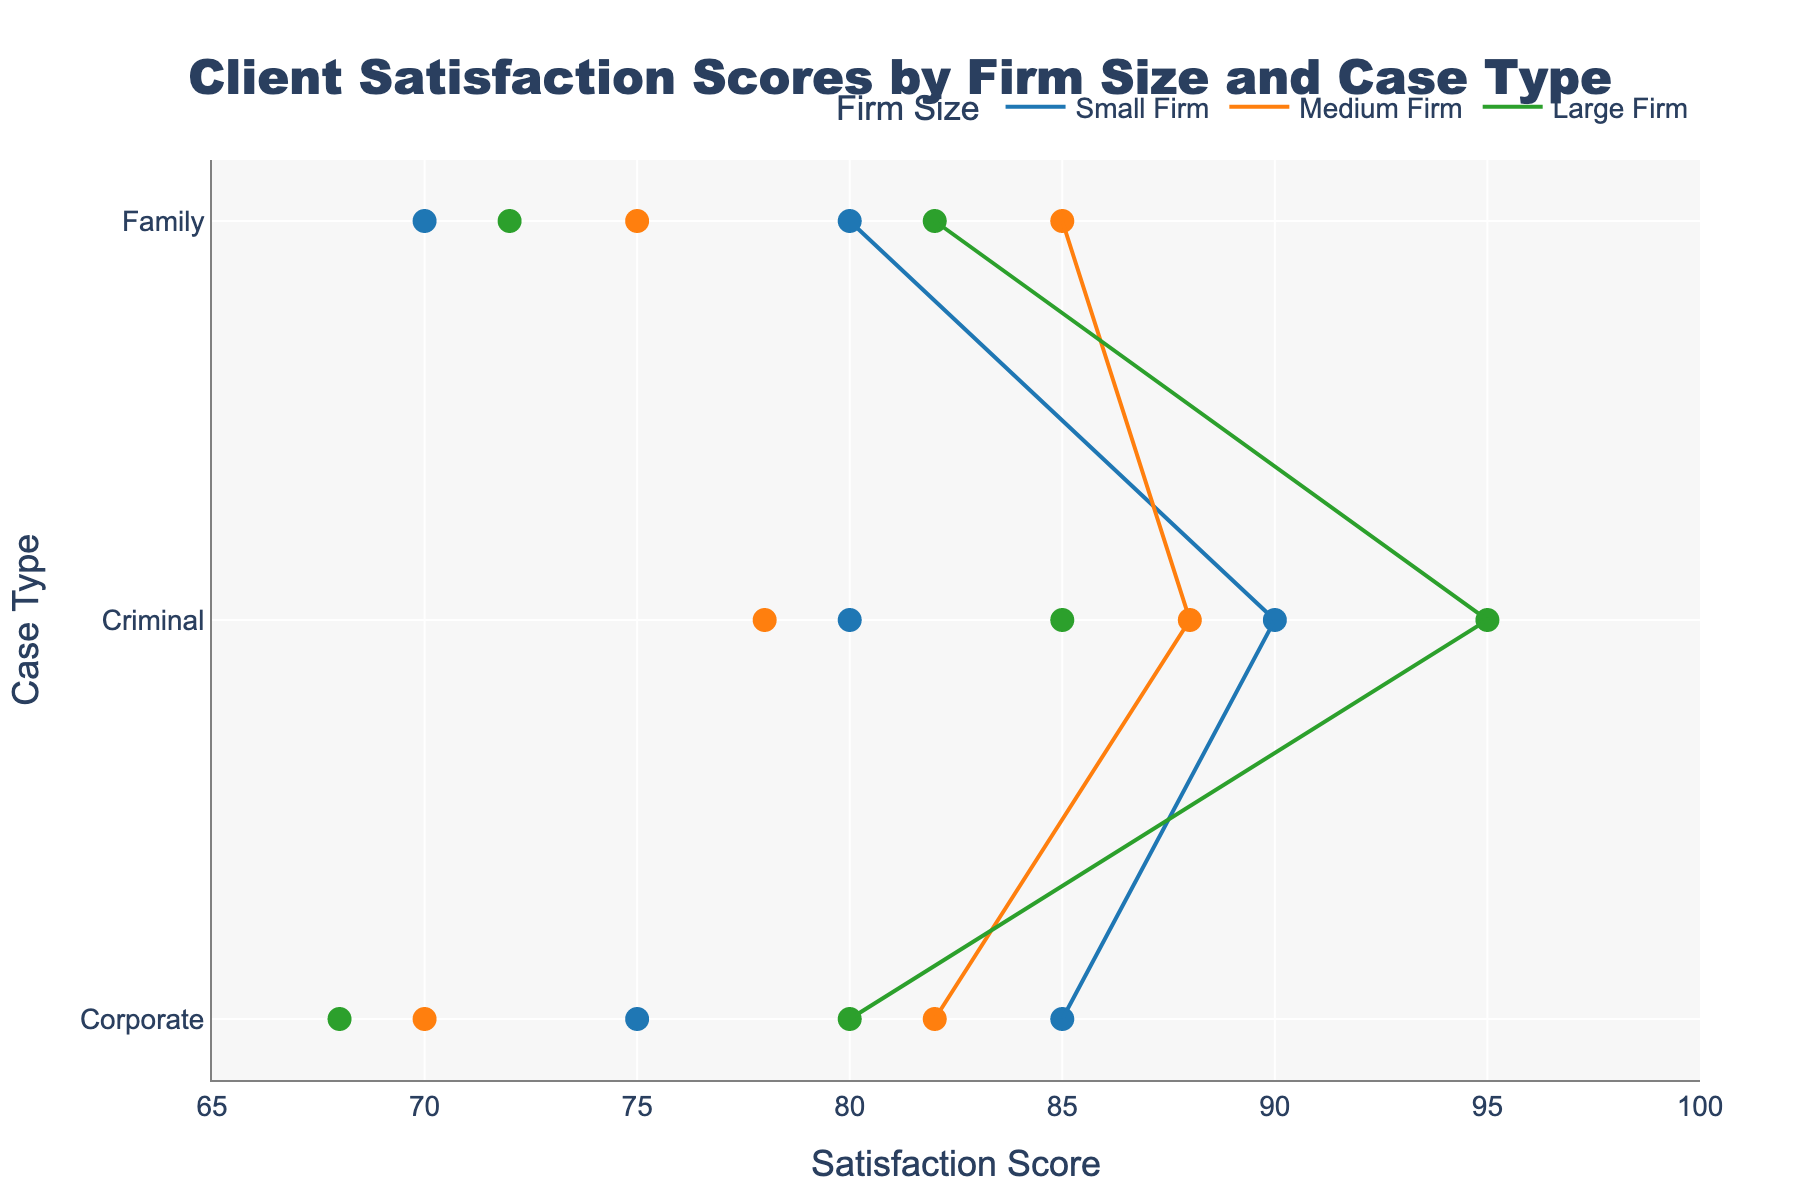What's the title of the figure? The title is usually found at the top of the figure. In this case, it reads "Client Satisfaction Scores by Firm Size and Case Type".
Answer: Client Satisfaction Scores by Firm Size and Case Type Which firm size category has the highest maximum satisfaction score for Criminal cases? Look for the highest dot in the Criminal category for each firm size. The Large firm has the highest with a score of 95.
Answer: Large What is the range of satisfaction scores for small firms handling Corporate cases? Identify the Min and Max Satisfaction Scores for small firms handling Corporate cases. The scores are 75 (Min) and 85 (Max).
Answer: 75 to 85 Compare the minimum satisfaction scores of Medium and Large firms for Family cases. Which is higher? Locate the minimum satisfaction scores for Medium and Large firms in the Family category; Medium has 75 and Large has 72.
Answer: Medium What is the average of the maximum satisfaction scores for Medium firms across all case types? Add the maximum scores for Medium firms in Corporate (82), Criminal (88), and Family (85), then divide by 3. (82 + 88 + 85) / 3 = 255 / 3
Answer: 85 Which case type shows the widest range in satisfaction scores within any firm size category? Evaluate the range (Max - Min) for each case type within each firm size. Large firms handling Criminal cases have the widest range (95 - 85 = 10).
Answer: Criminal (Large) How do the satisfaction scores for small firms in Family cases compare to large firms in value and range? Small firms have scores from 70 to 80; large firms range from 72 to 82. Both values and ranges indicate similar satisfaction levels.
Answer: Comparable Identify the case type with the smallest range in satisfaction scores for any firm size. Assess the range for each case type within each firm size; Medium firms handling Corporate cases have the smallest range (82 - 70 = 12).
Answer: Corporate (Medium) Which firm size shows the smallest variation in satisfaction scores for Corporate cases? Variations are Small (85 - 75 = 10), Medium (82 - 70 = 12), and Large (80 - 68 = 12). Small firms have the smallest variation.
Answer: Small Is there a case where the minimum satisfaction score of one firm size is higher than the maximum of another? Compare across all categories; in Criminal cases, the minimum score for Small firms (80) is higher than the maximum for Large firms (95). This scenario doesn't exist.
Answer: No 